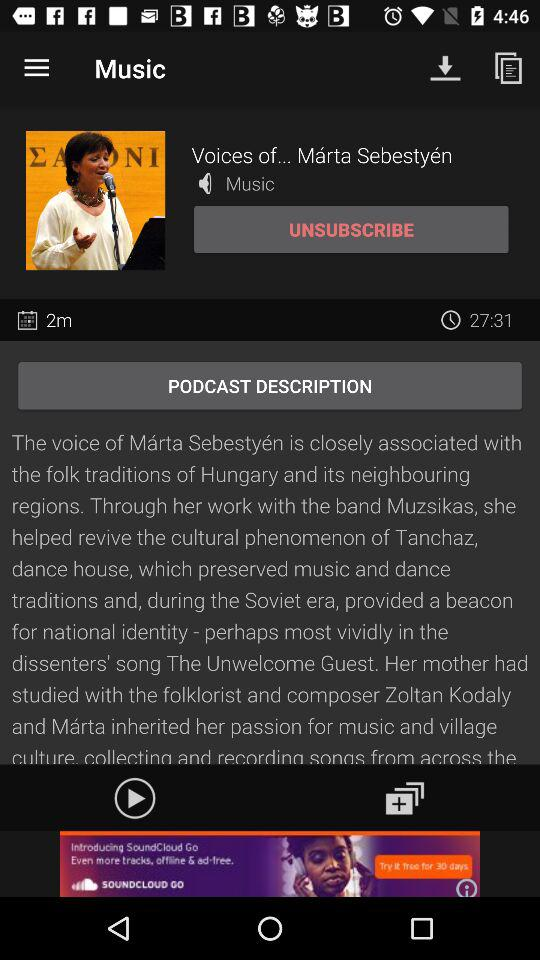What is the duration? The duration is 27 minutes and 31 seconds. 